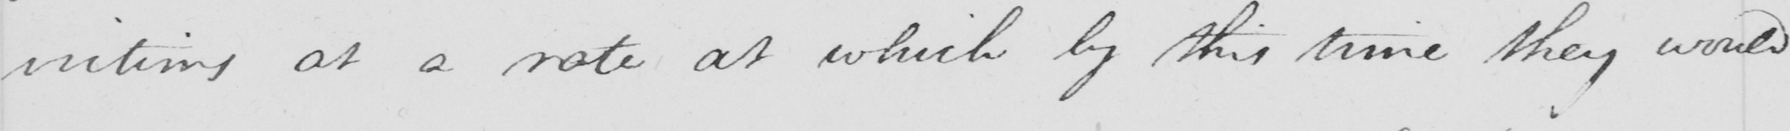What does this handwritten line say? victims at a rate at which by this time they would 